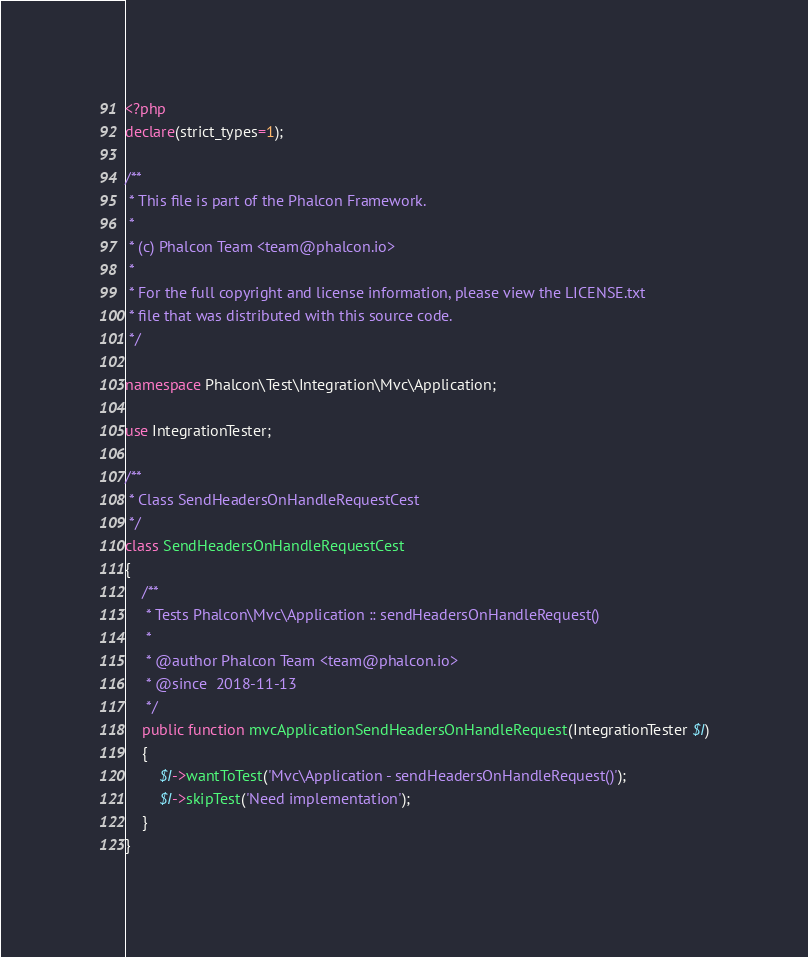<code> <loc_0><loc_0><loc_500><loc_500><_PHP_><?php
declare(strict_types=1);

/**
 * This file is part of the Phalcon Framework.
 *
 * (c) Phalcon Team <team@phalcon.io>
 *
 * For the full copyright and license information, please view the LICENSE.txt
 * file that was distributed with this source code.
 */

namespace Phalcon\Test\Integration\Mvc\Application;

use IntegrationTester;

/**
 * Class SendHeadersOnHandleRequestCest
 */
class SendHeadersOnHandleRequestCest
{
    /**
     * Tests Phalcon\Mvc\Application :: sendHeadersOnHandleRequest()
     *
     * @author Phalcon Team <team@phalcon.io>
     * @since  2018-11-13
     */
    public function mvcApplicationSendHeadersOnHandleRequest(IntegrationTester $I)
    {
        $I->wantToTest('Mvc\Application - sendHeadersOnHandleRequest()');
        $I->skipTest('Need implementation');
    }
}
</code> 